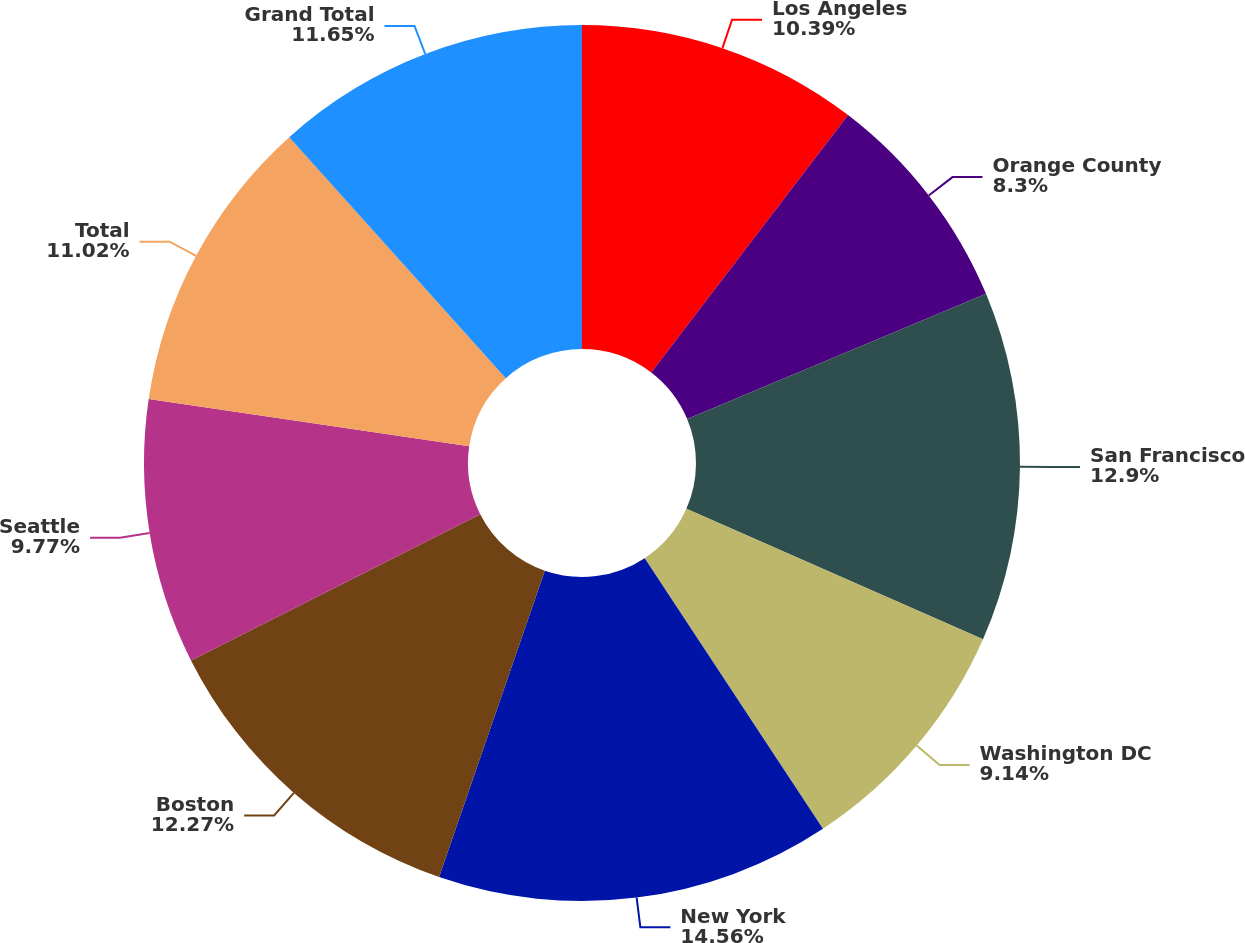<chart> <loc_0><loc_0><loc_500><loc_500><pie_chart><fcel>Los Angeles<fcel>Orange County<fcel>San Francisco<fcel>Washington DC<fcel>New York<fcel>Boston<fcel>Seattle<fcel>Total<fcel>Grand Total<nl><fcel>10.39%<fcel>8.3%<fcel>12.9%<fcel>9.14%<fcel>14.56%<fcel>12.27%<fcel>9.77%<fcel>11.02%<fcel>11.65%<nl></chart> 